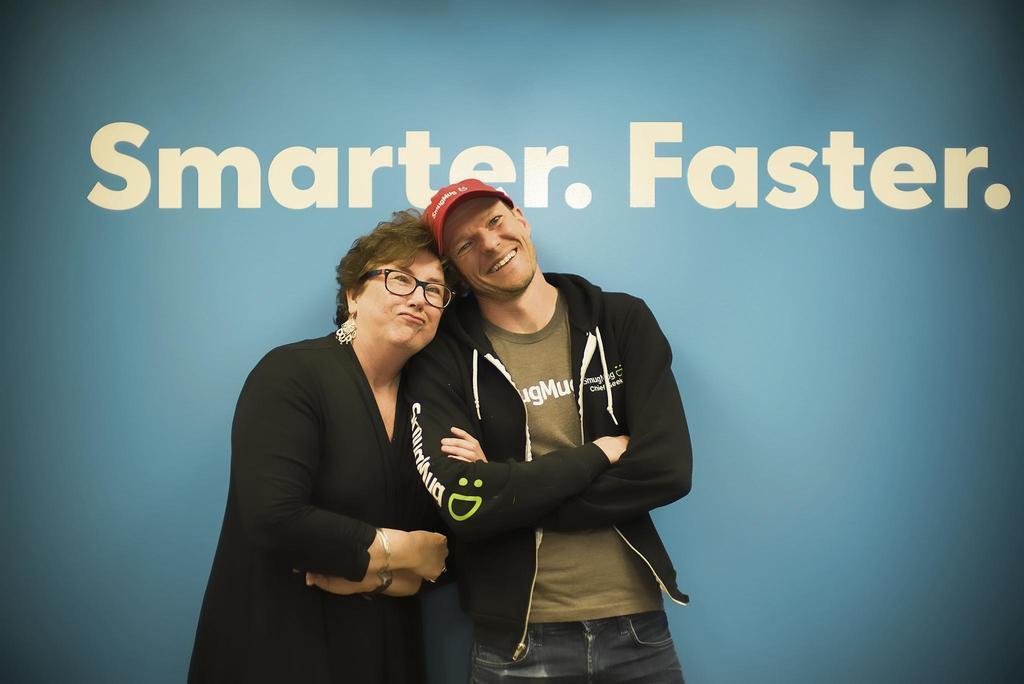How would you summarize this image in a sentence or two? In this image I can see a woman wearing black colored dress and a man wearing black colored jacket, jeans and red colored hat are standing. In the background I can see the blue colored surface on which I can see few words written with white color. 